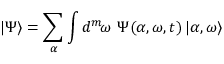<formula> <loc_0><loc_0><loc_500><loc_500>| \Psi \rangle = \sum _ { \alpha } \int d ^ { m } \, { \omega } \, \Psi ( { \alpha } , { \omega } , t ) \, | { \alpha } , { \omega } \rangle</formula> 